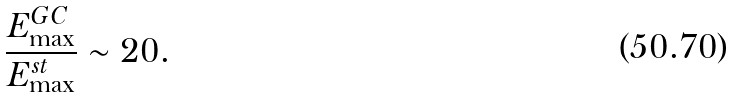<formula> <loc_0><loc_0><loc_500><loc_500>\frac { E _ { \max } ^ { G C } } { E _ { \max } ^ { s t } } \sim 2 0 .</formula> 